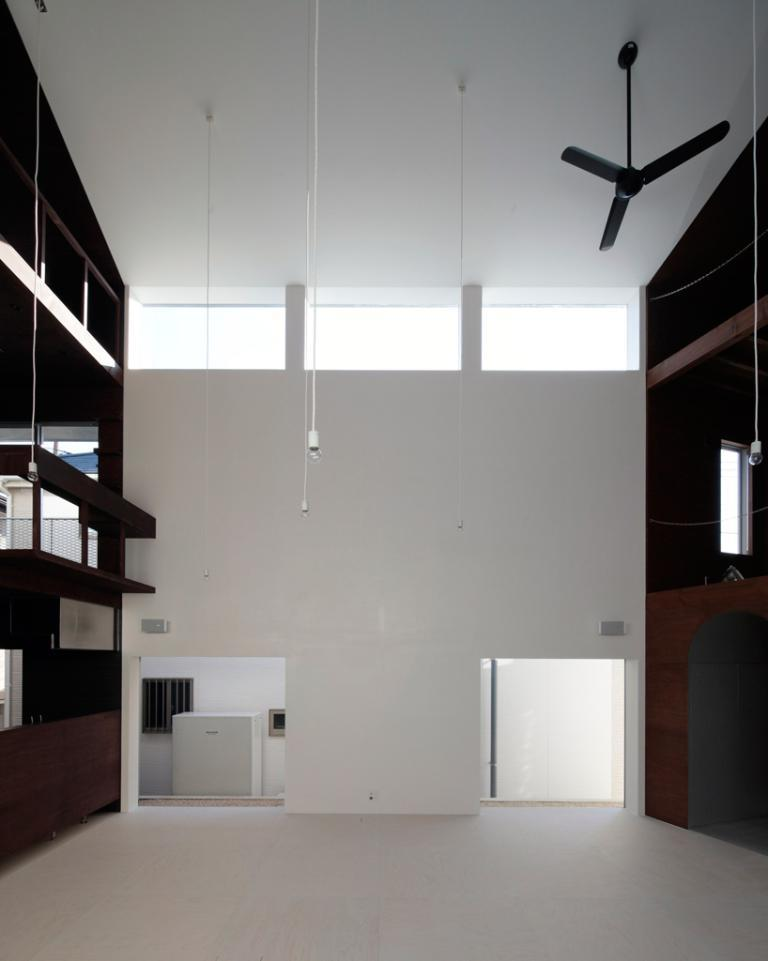What can be seen in the background of the image? In the background of the image, there is a wall, lights, a fan, and a fence. Can you describe the lighting in the image? Yes, there are lights visible in the background of the image. What type of structure is present in the background of the image? There is a fence in the background of the image. What might be used for cooling in the image? A fan is present in the background of the image, which could be used for cooling. What type of music can be heard playing in the background of the image? There is no music present in the image; it only contains visual elements. Is there a bathtub visible in the image? No, there is no bathtub present in the image. 